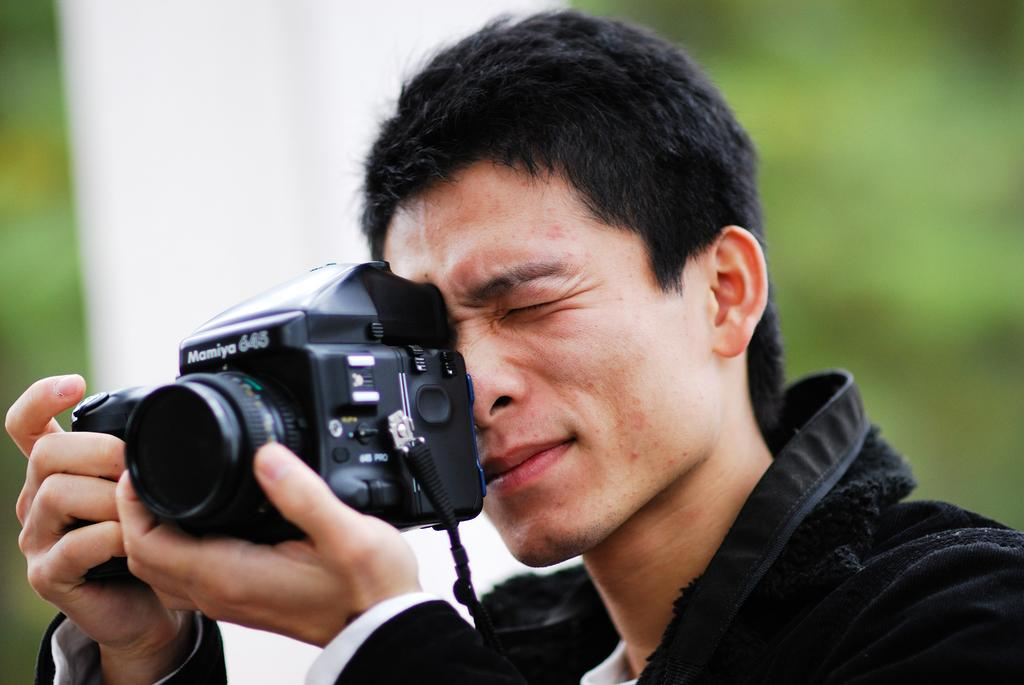Who is the main subject in the image? There is a man in the image. What is the man holding in the image? The man is holding a camera. What is the man doing with the camera? The man is taking a picture. What type of squirrel can be seen in the image? There is no squirrel present in the image. Can you describe the deer that is standing next to the man in the image? There is no deer present in the image. 